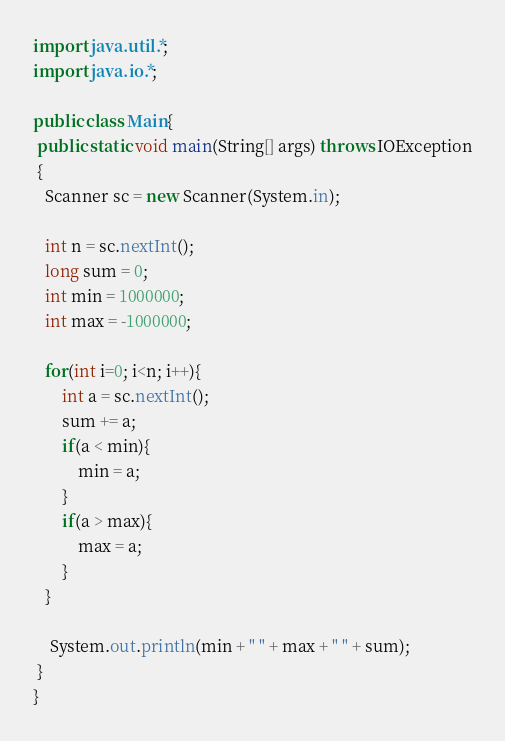Convert code to text. <code><loc_0><loc_0><loc_500><loc_500><_Java_>import java.util.*;
import java.io.*;

public class Main{
 public static void main(String[] args) throws IOException
 {
   Scanner sc = new Scanner(System.in);

   int n = sc.nextInt();
   long sum = 0;
   int min = 1000000;
   int max = -1000000;

   for(int i=0; i<n; i++){
       int a = sc.nextInt();
       sum += a;
       if(a < min){
           min = a;
       }
       if(a > max){
           max = a;
       }
   }

    System.out.println(min + " " + max + " " + sum);
 }
}</code> 